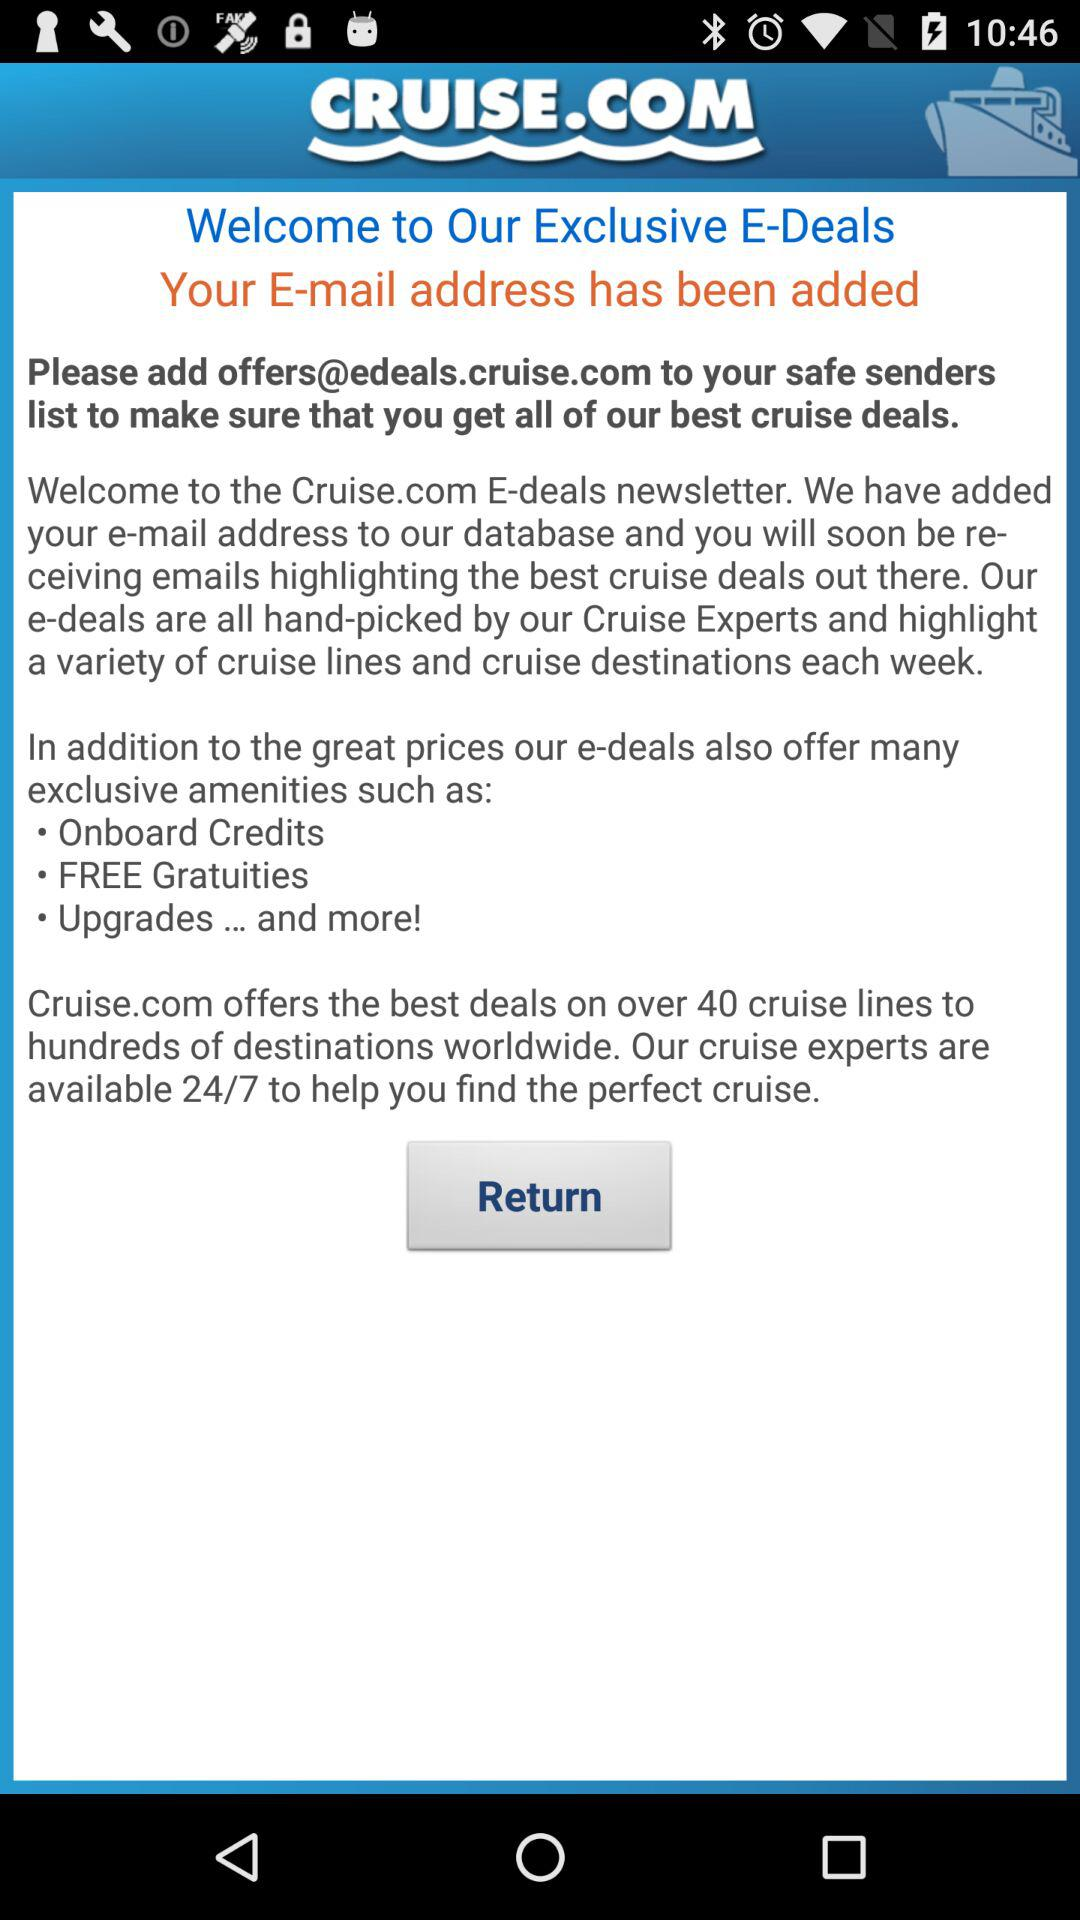What are the amenities offered by e-deals? The amenities offered by e-deals are onboard credits, free gratuities, upgrades and more. 